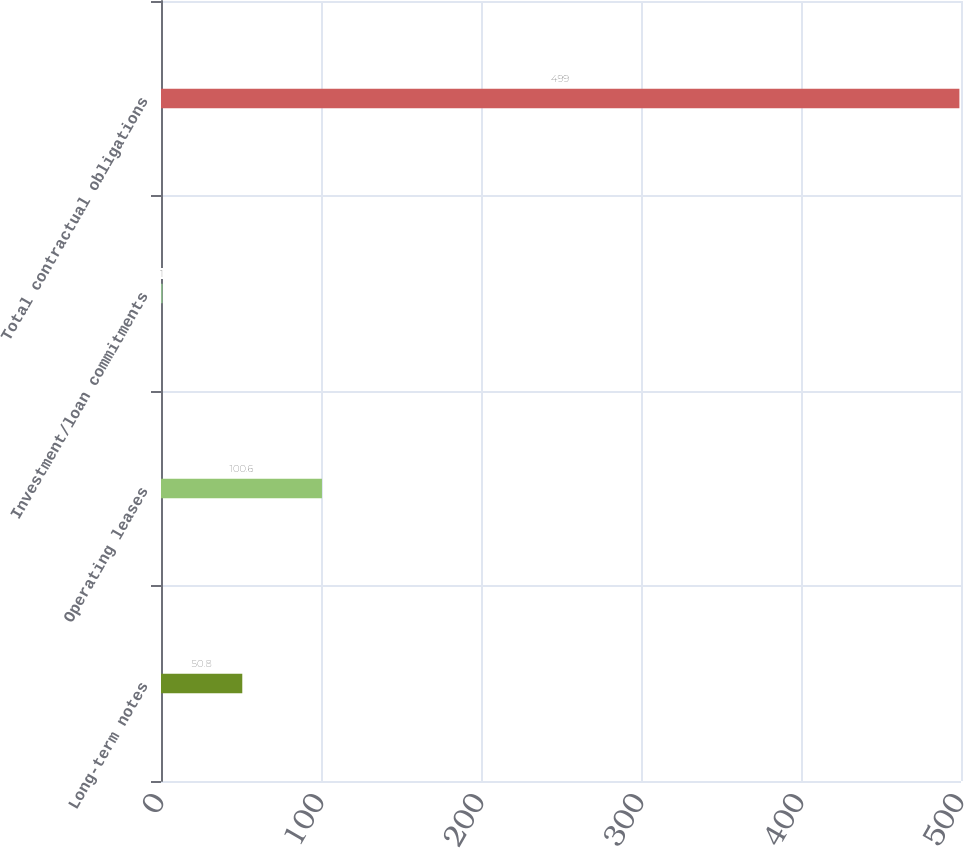Convert chart. <chart><loc_0><loc_0><loc_500><loc_500><bar_chart><fcel>Long-term notes<fcel>Operating leases<fcel>Investment/loan commitments<fcel>Total contractual obligations<nl><fcel>50.8<fcel>100.6<fcel>1<fcel>499<nl></chart> 